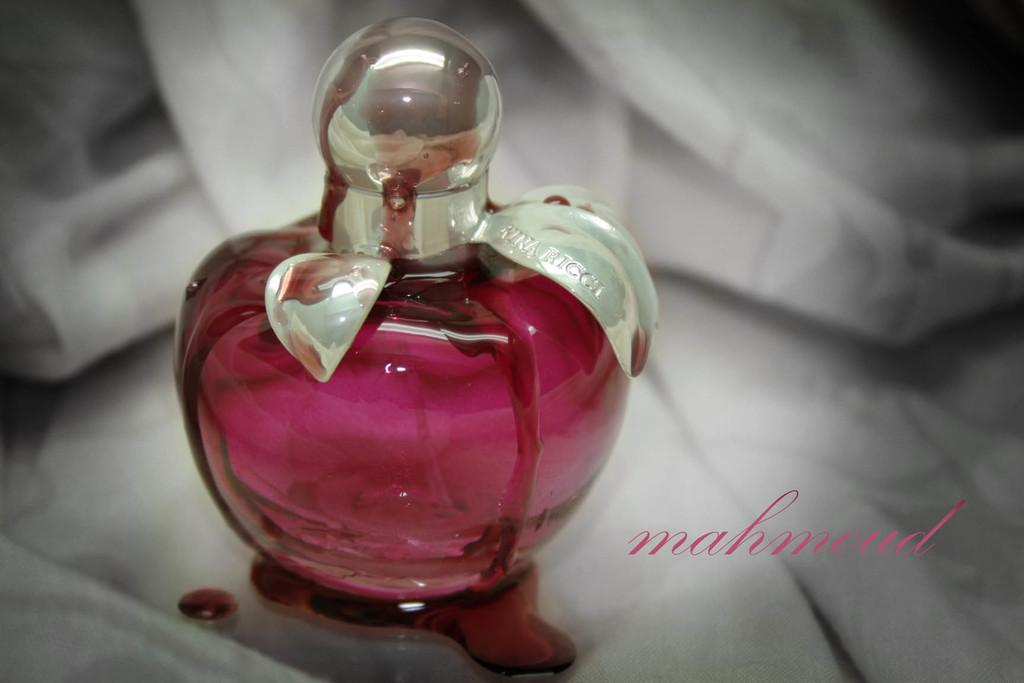Provide a one-sentence caption for the provided image. The ad showcases a burgundy perfume bottle for sale. 